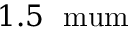<formula> <loc_0><loc_0><loc_500><loc_500>1 . 5 \ m u m</formula> 